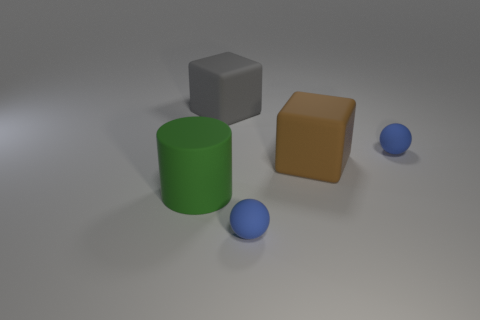Add 4 large gray matte cubes. How many objects exist? 9 Subtract all balls. How many objects are left? 3 Add 4 matte cubes. How many matte cubes exist? 6 Subtract 1 brown blocks. How many objects are left? 4 Subtract all purple matte objects. Subtract all large green matte objects. How many objects are left? 4 Add 4 big brown matte blocks. How many big brown matte blocks are left? 5 